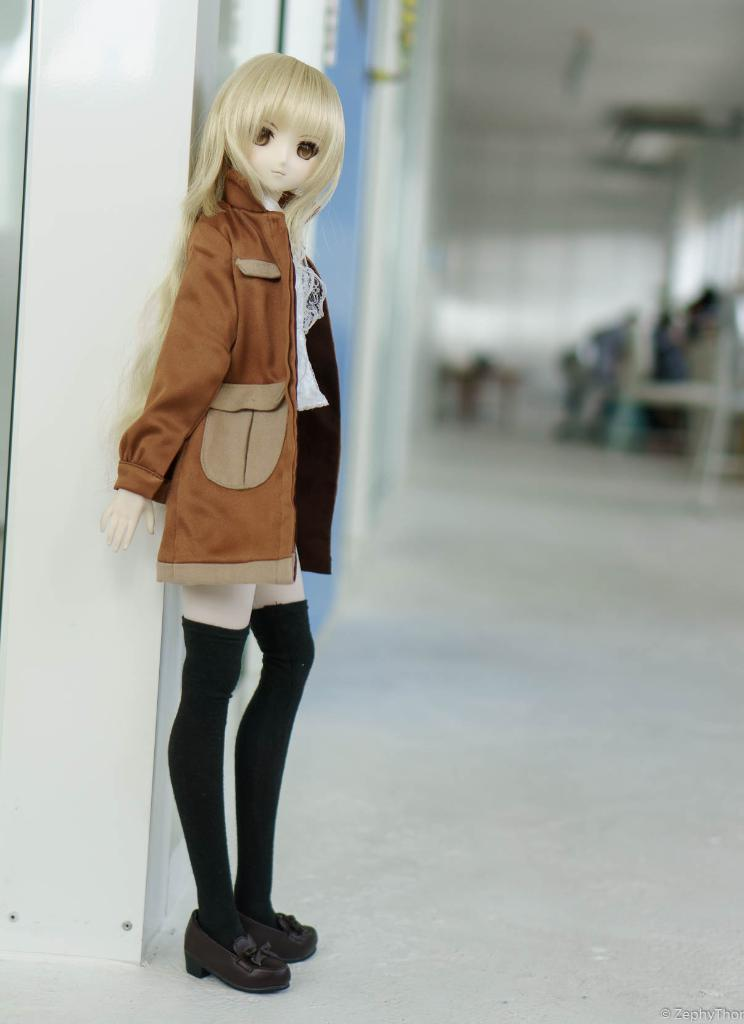What is the main structure visible in the image? There is a wall in the image. What object is located in the front of the image? There is a toy in the front of the image. How would you describe the background of the image? The background of the image is blurred. Can you tell me how many women are sitting on the seat in the image? There are no women or seats present in the image. What type of root can be seen growing from the wall in the image? There is no root growing from the wall in the image. 